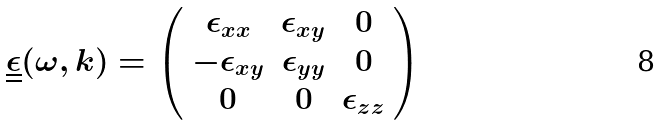<formula> <loc_0><loc_0><loc_500><loc_500>\underline { \underline { \epsilon } } ( \omega , k ) = \left ( \begin{array} { c c c } \epsilon _ { x x } & \epsilon _ { x y } & 0 \\ - \epsilon _ { x y } & \epsilon _ { y y } & 0 \\ 0 & 0 & \epsilon _ { z z } \end{array} \right )</formula> 